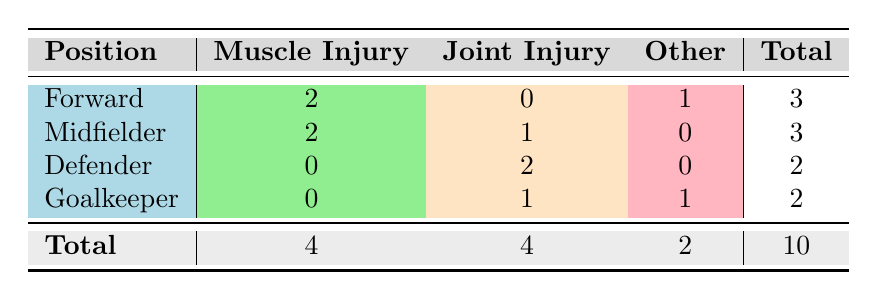What is the total number of muscle injuries reported? The table shows that there are 4 muscle injuries reported, as stated in the respective column under the Total row
Answer: 4 Which position has the highest number of joint injuries? By looking at the joint injury column, both Midfielder and Defender positions each have 2 joint injuries, which is the highest compared to other positions
Answer: Midfielder and Defender How many total injuries are reported for goalkeepers? The goalkeeper row shows a total of 2 injuries reported, as stated in the Total column for that position
Answer: 2 Is it true that forwards have more muscle injuries than both defenders and goalkeepers combined? Forwards have 2 muscle injuries while defenders have 0 and goalkeepers have 0, so combined they have 0. Thus, 2 is greater than 0
Answer: Yes What is the average number of injuries reported by position? The total injuries across all positions is 10, with 4 positions reported. To find the average, we divide 10 by 4, which equals 2.5
Answer: 2.5 What is the total number of 'Other' injuries across all positions? The total number of 'Other' injuries can be found by adding the Other column values: 1 (Forward) + 0 (Midfielder) + 0 (Defender) + 1 (Goalkeeper) = 2
Answer: 2 Which position has reported the least number of total injuries? By examining the Total column, both Defender and Goalkeeper positions have each reported a total of 2 injuries, which is less than the others
Answer: Defender and Goalkeeper How many more muscle injuries are there than injuries categorized as 'Other'? There are 4 muscle injuries and 2 'Other' injuries. The difference is 4 - 2, which equals 2
Answer: 2 Which injury type is least represented in the table? By analyzing the types of injuries, the least represented injury types in the two columns are "Achilles Tendon" and "Knee Injury", as seen in their respective counts
Answer: Achilles Tendon and Knee Injury 